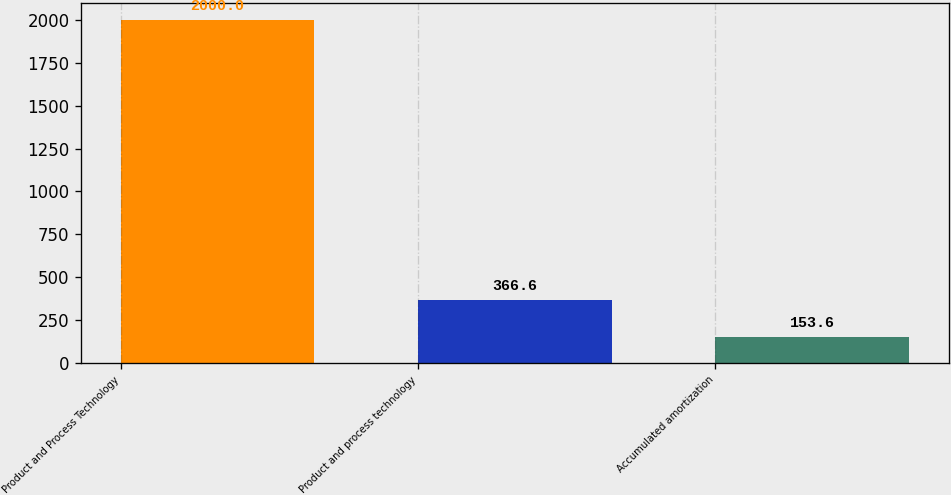<chart> <loc_0><loc_0><loc_500><loc_500><bar_chart><fcel>Product and Process Technology<fcel>Product and process technology<fcel>Accumulated amortization<nl><fcel>2000<fcel>366.6<fcel>153.6<nl></chart> 